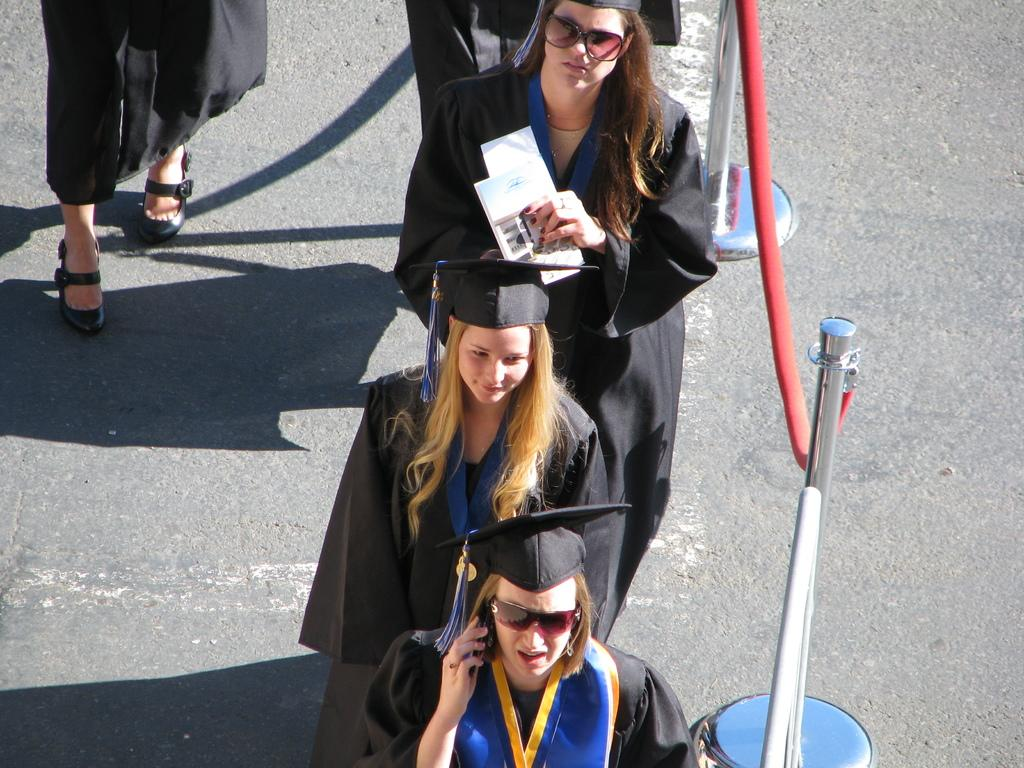Who is present in the image? There are women in the image. What are the women wearing? The women are wearing graduation dresses. What color are the graduation dresses? The graduation dresses are black in color. Can you see any pickles in the image? There are no pickles present in the image. How many fingers are visible on the women's hands in the image? The number of fingers cannot be determined from the image, as hands are not visible. 